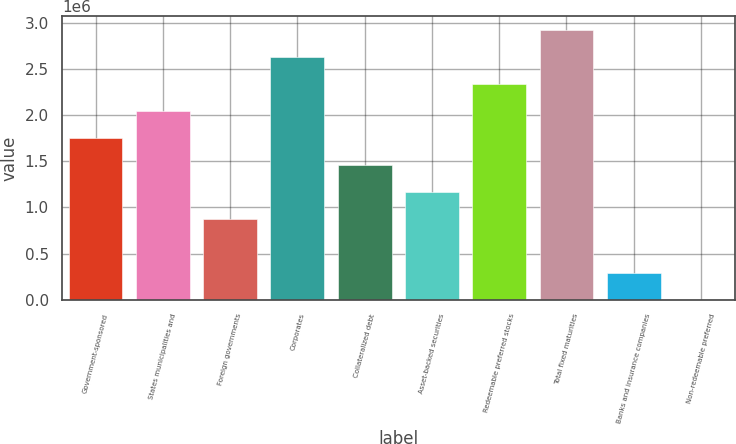Convert chart to OTSL. <chart><loc_0><loc_0><loc_500><loc_500><bar_chart><fcel>Government-sponsored<fcel>States municipalities and<fcel>Foreign governments<fcel>Corporates<fcel>Collateralized debt<fcel>Asset-backed securities<fcel>Redeemable preferred stocks<fcel>Total fixed maturities<fcel>Banks and insurance companies<fcel>Non-redeemable preferred<nl><fcel>1.75548e+06<fcel>2.04806e+06<fcel>877740<fcel>2.63322e+06<fcel>1.4629e+06<fcel>1.17032e+06<fcel>2.34064e+06<fcel>2.9258e+06<fcel>292580<fcel>0.24<nl></chart> 